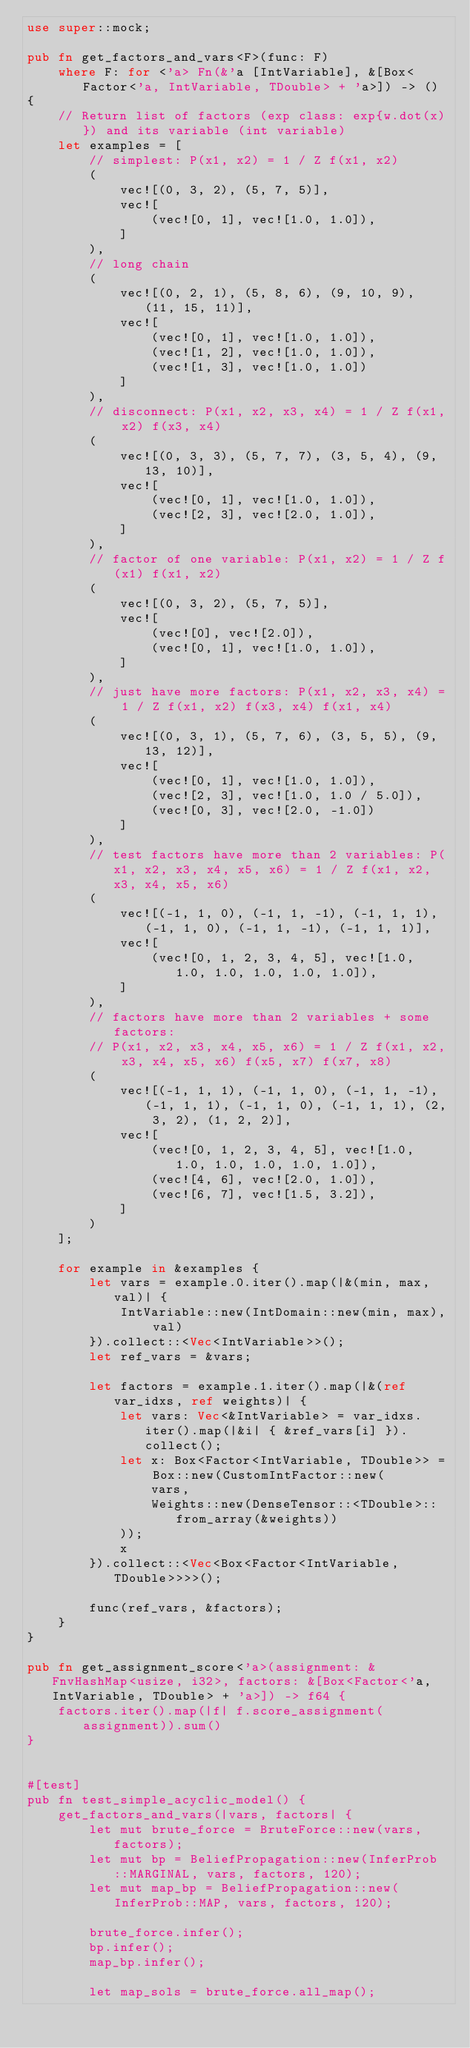<code> <loc_0><loc_0><loc_500><loc_500><_Rust_>use super::mock;

pub fn get_factors_and_vars<F>(func: F)
    where F: for <'a> Fn(&'a [IntVariable], &[Box<Factor<'a, IntVariable, TDouble> + 'a>]) -> ()
{
    // Return list of factors (exp class: exp{w.dot(x)}) and its variable (int variable)
    let examples = [
    	// simplest: P(x1, x2) = 1 / Z f(x1, x2)
        (
        	vec![(0, 3, 2), (5, 7, 5)],
        	vec![
	        	(vec![0, 1], vec![1.0, 1.0]),
	    	]
	    ),
	    // long chain
	    (
	    	vec![(0, 2, 1), (5, 8, 6), (9, 10, 9), (11, 15, 11)],
	    	vec![
	        	(vec![0, 1], vec![1.0, 1.0]),
	        	(vec![1, 2], vec![1.0, 1.0]),
	        	(vec![1, 3], vec![1.0, 1.0])
	    	]
	    ),
	    // disconnect: P(x1, x2, x3, x4) = 1 / Z f(x1, x2) f(x3, x4)
	    (
	    	vec![(0, 3, 3), (5, 7, 7), (3, 5, 4), (9, 13, 10)],
	    	vec![
	        	(vec![0, 1], vec![1.0, 1.0]),
	        	(vec![2, 3], vec![2.0, 1.0]),
	    	]
	    ),
	    // factor of one variable: P(x1, x2) = 1 / Z f(x1) f(x1, x2)
	    (
	    	vec![(0, 3, 2), (5, 7, 5)],
	    	vec![
	        	(vec![0], vec![2.0]),
	        	(vec![0, 1], vec![1.0, 1.0]),
	    	]
	    ),
	    // just have more factors: P(x1, x2, x3, x4) = 1 / Z f(x1, x2) f(x3, x4) f(x1, x4)
	    (
	    	vec![(0, 3, 1), (5, 7, 6), (3, 5, 5), (9, 13, 12)],
	    	vec![
	        	(vec![0, 1], vec![1.0, 1.0]),
	        	(vec![2, 3], vec![1.0, 1.0 / 5.0]),
	        	(vec![0, 3], vec![2.0, -1.0])
	    	]
	    ),
	    // test factors have more than 2 variables: P(x1, x2, x3, x4, x5, x6) = 1 / Z f(x1, x2, x3, x4, x5, x6)
	    (
	    	vec![(-1, 1, 0), (-1, 1, -1), (-1, 1, 1), (-1, 1, 0), (-1, 1, -1), (-1, 1, 1)],
	    	vec![
	        	(vec![0, 1, 2, 3, 4, 5], vec![1.0, 1.0, 1.0, 1.0, 1.0, 1.0]),
	    	]
	    ),
	    // factors have more than 2 variables + some factors:
	    // P(x1, x2, x3, x4, x5, x6) = 1 / Z f(x1, x2, x3, x4, x5, x6) f(x5, x7) f(x7, x8)
	    (
	    	vec![(-1, 1, 1), (-1, 1, 0), (-1, 1, -1), (-1, 1, 1), (-1, 1, 0), (-1, 1, 1), (2, 3, 2), (1, 2, 2)],
	    	vec![
	        	(vec![0, 1, 2, 3, 4, 5], vec![1.0, 1.0, 1.0, 1.0, 1.0, 1.0]),
	        	(vec![4, 6], vec![2.0, 1.0]),
	        	(vec![6, 7], vec![1.5, 3.2]),
	    	]
	    )
    ];

    for example in &examples {
        let vars = example.0.iter().map(|&(min, max, val)| {
            IntVariable::new(IntDomain::new(min, max), val)
        }).collect::<Vec<IntVariable>>();
        let ref_vars = &vars;

        let factors = example.1.iter().map(|&(ref var_idxs, ref weights)| {
            let vars: Vec<&IntVariable> = var_idxs.iter().map(|&i| { &ref_vars[i] }).collect();
			let x: Box<Factor<IntVariable, TDouble>> = Box::new(CustomIntFactor::new(
                vars,
                Weights::new(DenseTensor::<TDouble>::from_array(&weights))
            ));
            x
		}).collect::<Vec<Box<Factor<IntVariable, TDouble>>>>();

        func(ref_vars, &factors);
    }
}

pub fn get_assignment_score<'a>(assignment: &FnvHashMap<usize, i32>, factors: &[Box<Factor<'a, IntVariable, TDouble> + 'a>]) -> f64 {
    factors.iter().map(|f| f.score_assignment(assignment)).sum()
}


#[test]
pub fn test_simple_acyclic_model() {
    get_factors_and_vars(|vars, factors| {
        let mut brute_force = BruteForce::new(vars, factors);
        let mut bp = BeliefPropagation::new(InferProb::MARGINAL, vars, factors, 120);
        let mut map_bp = BeliefPropagation::new(InferProb::MAP, vars, factors, 120);

        brute_force.infer();
        bp.infer();
        map_bp.infer();

        let map_sols = brute_force.all_map();</code> 